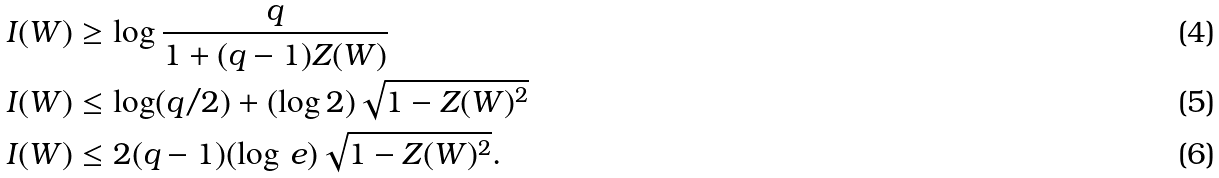<formula> <loc_0><loc_0><loc_500><loc_500>I ( W ) & \geq \log \frac { q } { 1 + ( q - 1 ) Z ( W ) } \\ I ( W ) & \leq \log ( q / 2 ) + ( \log 2 ) \sqrt { 1 - Z ( W ) ^ { 2 } } \\ I ( W ) & \leq 2 ( q - 1 ) ( \log \, e ) \sqrt { 1 - Z ( W ) ^ { 2 } } .</formula> 